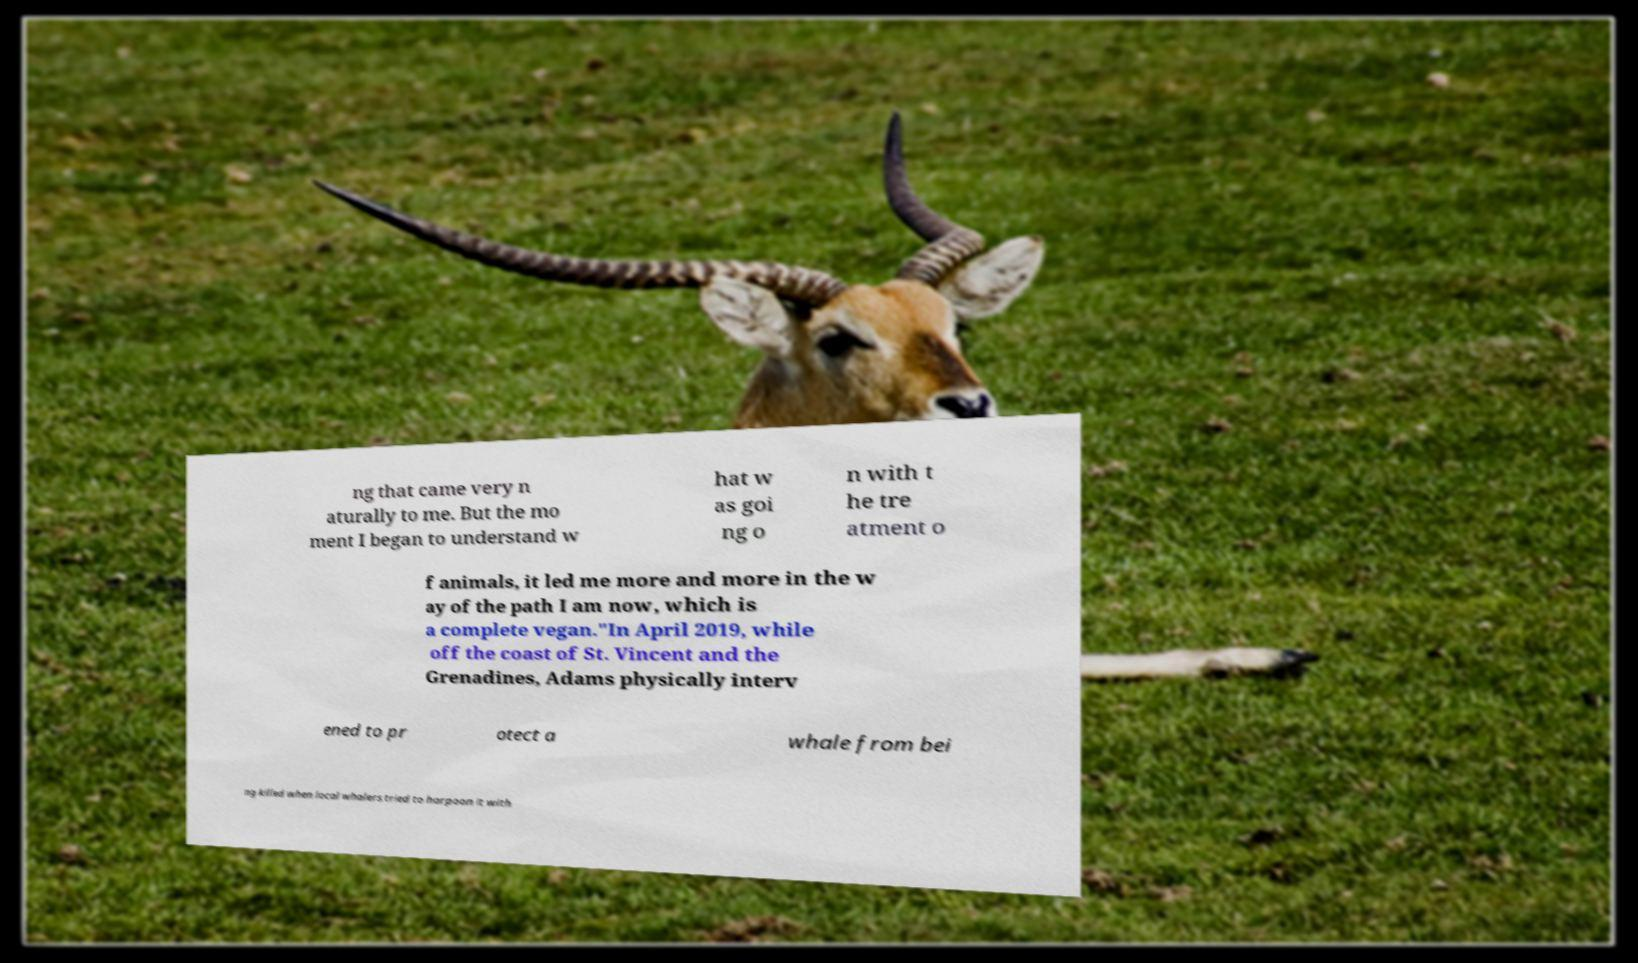Please read and relay the text visible in this image. What does it say? ng that came very n aturally to me. But the mo ment I began to understand w hat w as goi ng o n with t he tre atment o f animals, it led me more and more in the w ay of the path I am now, which is a complete vegan."In April 2019, while off the coast of St. Vincent and the Grenadines, Adams physically interv ened to pr otect a whale from bei ng killed when local whalers tried to harpoon it with 